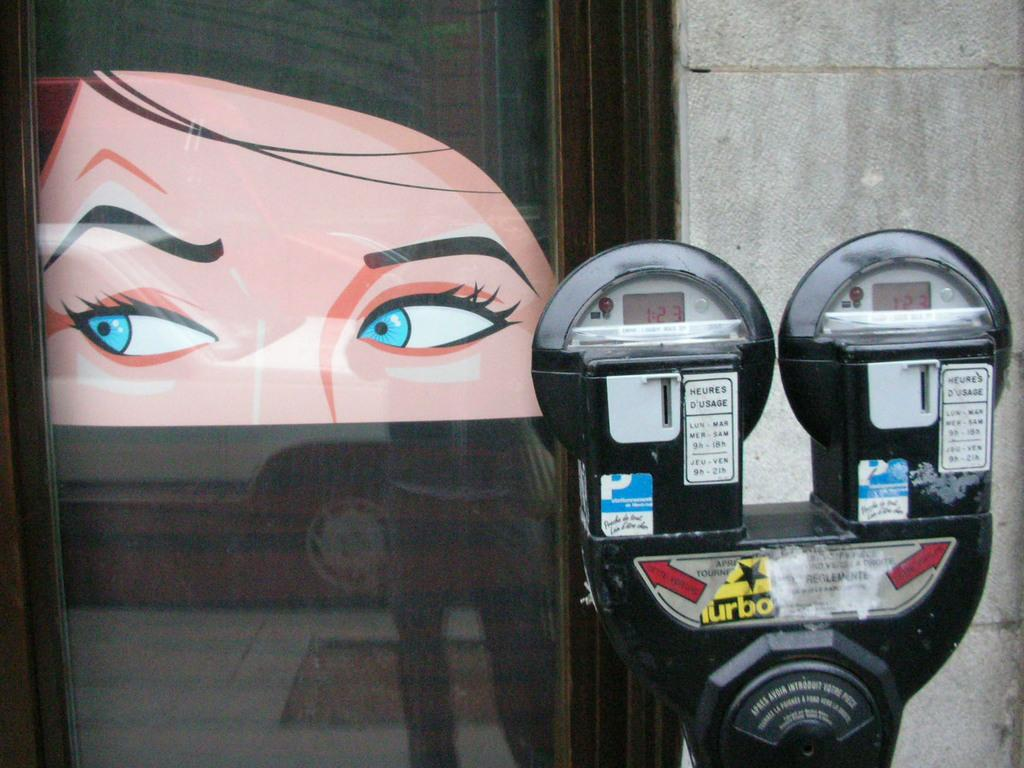<image>
Summarize the visual content of the image. A parking meter showing the time 1:23 on both clocks with a Turbo yellow sticker on it. 